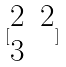Convert formula to latex. <formula><loc_0><loc_0><loc_500><loc_500>[ \begin{matrix} 2 & 2 \\ 3 \end{matrix} ]</formula> 